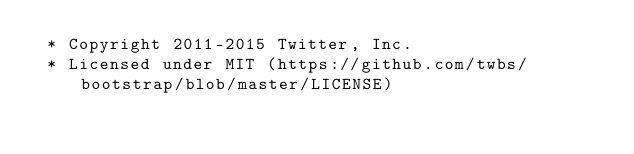Convert code to text. <code><loc_0><loc_0><loc_500><loc_500><_CSS_> * Copyright 2011-2015 Twitter, Inc.
 * Licensed under MIT (https://github.com/twbs/bootstrap/blob/master/LICENSE)</code> 